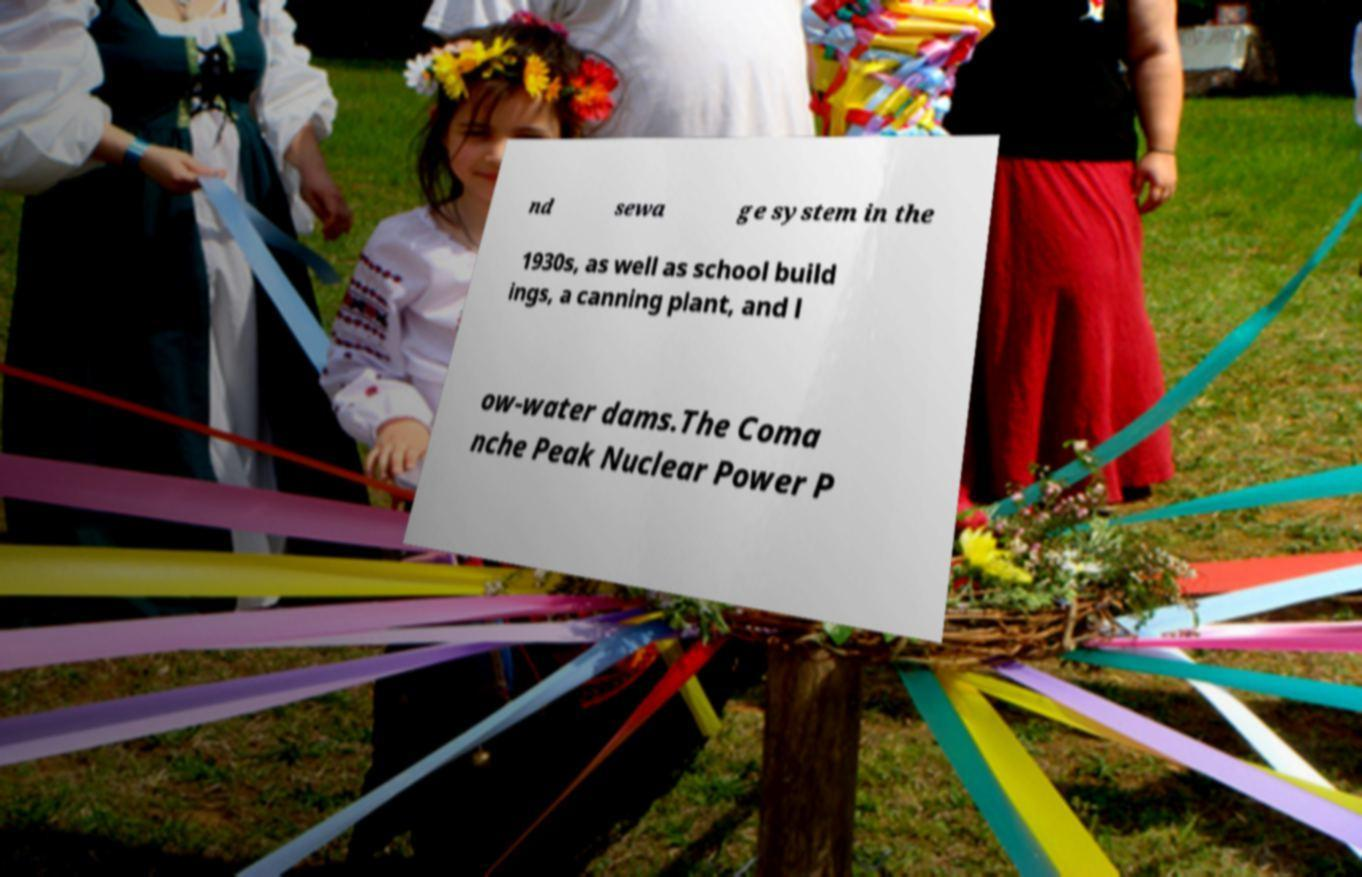For documentation purposes, I need the text within this image transcribed. Could you provide that? nd sewa ge system in the 1930s, as well as school build ings, a canning plant, and l ow-water dams.The Coma nche Peak Nuclear Power P 